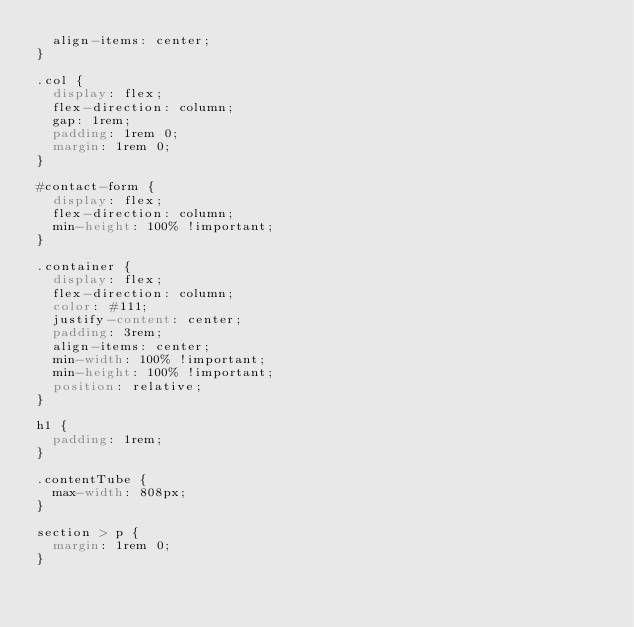<code> <loc_0><loc_0><loc_500><loc_500><_CSS_>  align-items: center;
}

.col {
  display: flex;
  flex-direction: column;
  gap: 1rem;
  padding: 1rem 0;
  margin: 1rem 0;
}

#contact-form {
  display: flex;
  flex-direction: column;
  min-height: 100% !important;
}

.container {
  display: flex;
  flex-direction: column;
  color: #111;
  justify-content: center;
  padding: 3rem;
  align-items: center;
  min-width: 100% !important;
  min-height: 100% !important;
  position: relative;
}

h1 {
  padding: 1rem;
}

.contentTube {
  max-width: 808px;
}

section > p {
  margin: 1rem 0;
}
</code> 